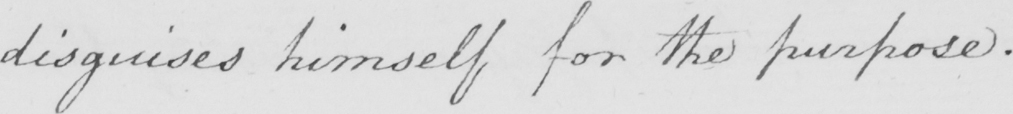Please transcribe the handwritten text in this image. disguises himself for the purpose . 